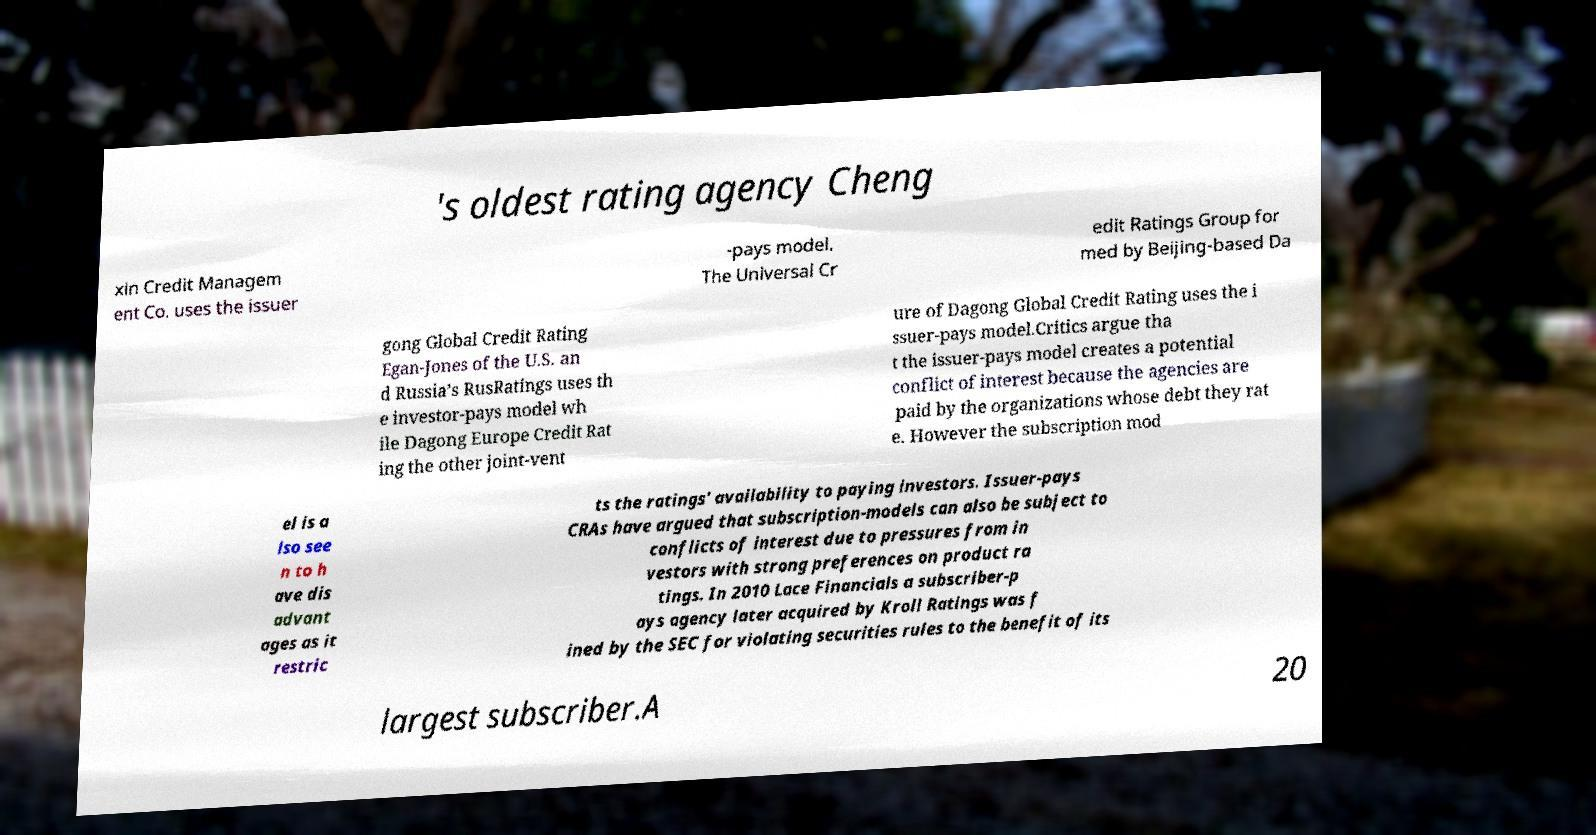Can you accurately transcribe the text from the provided image for me? 's oldest rating agency Cheng xin Credit Managem ent Co. uses the issuer -pays model. The Universal Cr edit Ratings Group for med by Beijing-based Da gong Global Credit Rating Egan-Jones of the U.S. an d Russia’s RusRatings uses th e investor-pays model wh ile Dagong Europe Credit Rat ing the other joint-vent ure of Dagong Global Credit Rating uses the i ssuer-pays model.Critics argue tha t the issuer-pays model creates a potential conflict of interest because the agencies are paid by the organizations whose debt they rat e. However the subscription mod el is a lso see n to h ave dis advant ages as it restric ts the ratings' availability to paying investors. Issuer-pays CRAs have argued that subscription-models can also be subject to conflicts of interest due to pressures from in vestors with strong preferences on product ra tings. In 2010 Lace Financials a subscriber-p ays agency later acquired by Kroll Ratings was f ined by the SEC for violating securities rules to the benefit of its largest subscriber.A 20 